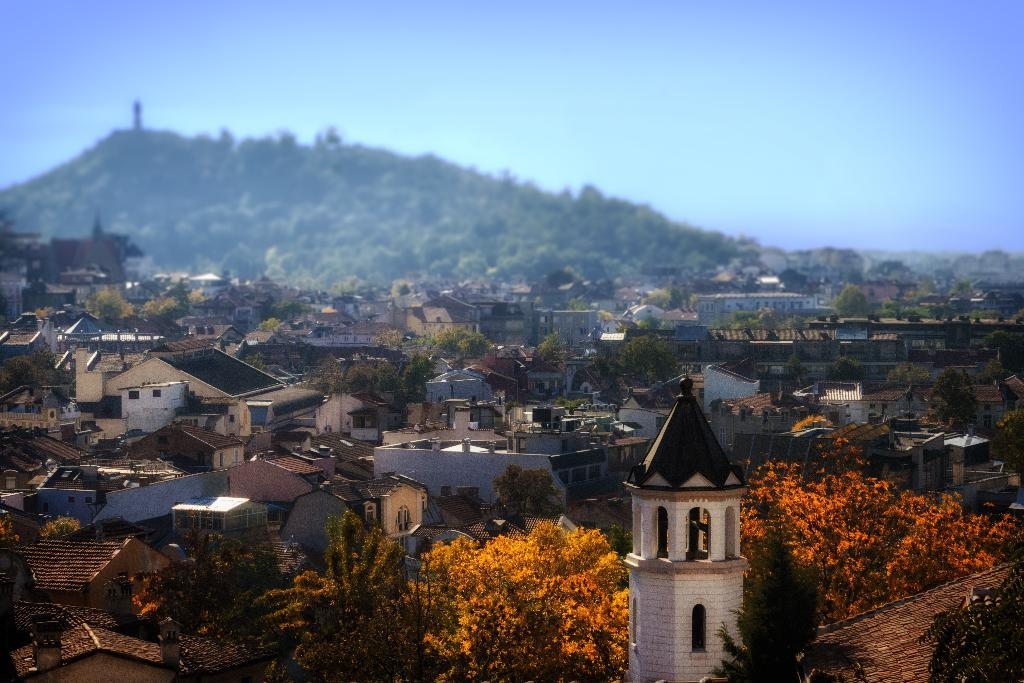What type of natural elements can be seen in the image? There are trees in the image. What type of man-made structures can be seen in the image? There are buildings in the image. Where are the trees and buildings located in the image? The trees and buildings are located at the bottom of the image. What is visible in the background of the image? There is a mountain in the background of the image. What is visible at the top of the image? The sky is visible at the top of the image. What type of yoke is being used by the trees in the image? There is no yoke present in the image; it features trees and buildings. What type of apparel is being worn by the mountain in the image? There is no apparel present in the image; it features a mountain in the background. 